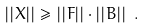Convert formula to latex. <formula><loc_0><loc_0><loc_500><loc_500>| | X | | \geq | | F | | \cdot | | B | | \ .</formula> 